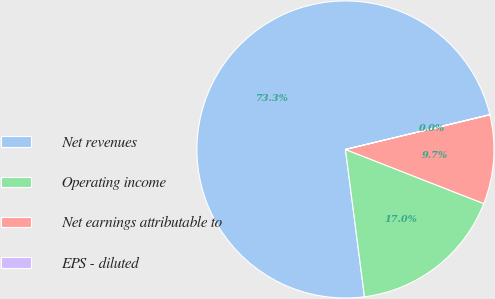Convert chart. <chart><loc_0><loc_0><loc_500><loc_500><pie_chart><fcel>Net revenues<fcel>Operating income<fcel>Net earnings attributable to<fcel>EPS - diluted<nl><fcel>73.29%<fcel>17.02%<fcel>9.69%<fcel>0.01%<nl></chart> 